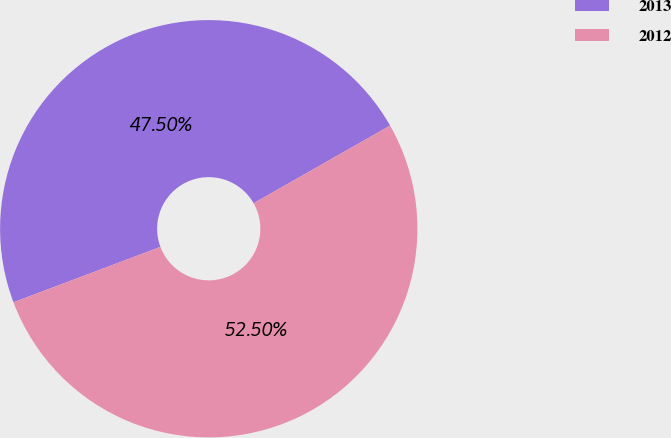<chart> <loc_0><loc_0><loc_500><loc_500><pie_chart><fcel>2013<fcel>2012<nl><fcel>47.5%<fcel>52.5%<nl></chart> 